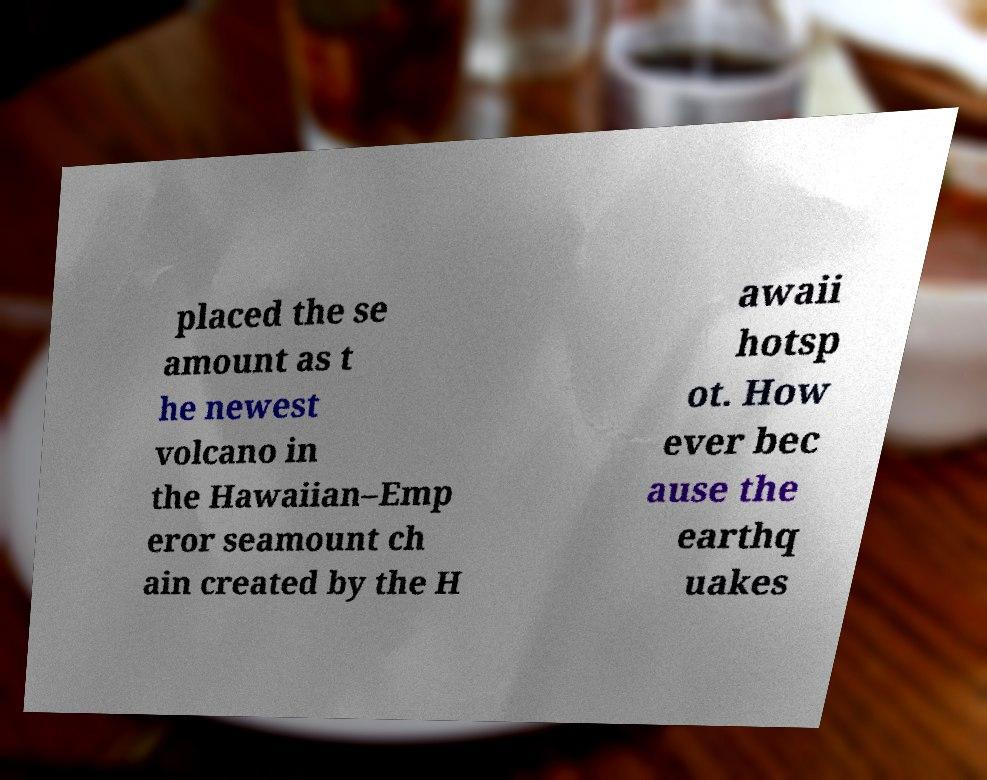Can you accurately transcribe the text from the provided image for me? placed the se amount as t he newest volcano in the Hawaiian–Emp eror seamount ch ain created by the H awaii hotsp ot. How ever bec ause the earthq uakes 